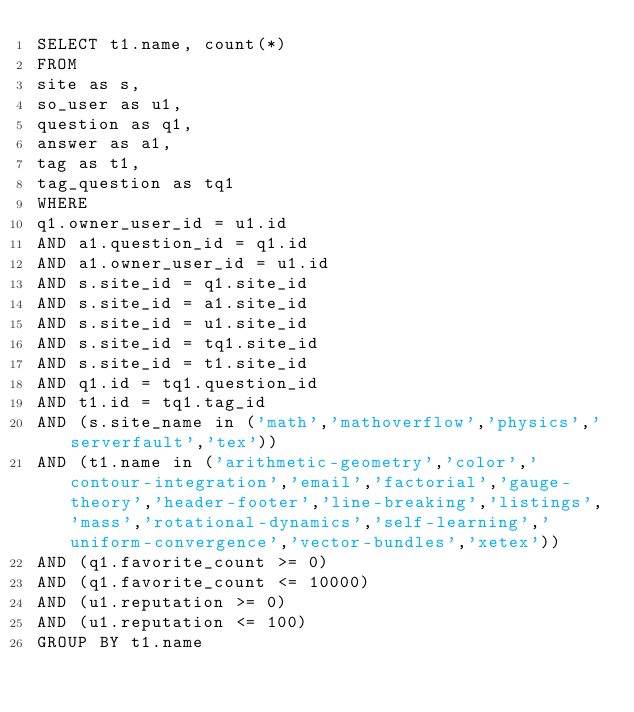Convert code to text. <code><loc_0><loc_0><loc_500><loc_500><_SQL_>SELECT t1.name, count(*)
FROM
site as s,
so_user as u1,
question as q1,
answer as a1,
tag as t1,
tag_question as tq1
WHERE
q1.owner_user_id = u1.id
AND a1.question_id = q1.id
AND a1.owner_user_id = u1.id
AND s.site_id = q1.site_id
AND s.site_id = a1.site_id
AND s.site_id = u1.site_id
AND s.site_id = tq1.site_id
AND s.site_id = t1.site_id
AND q1.id = tq1.question_id
AND t1.id = tq1.tag_id
AND (s.site_name in ('math','mathoverflow','physics','serverfault','tex'))
AND (t1.name in ('arithmetic-geometry','color','contour-integration','email','factorial','gauge-theory','header-footer','line-breaking','listings','mass','rotational-dynamics','self-learning','uniform-convergence','vector-bundles','xetex'))
AND (q1.favorite_count >= 0)
AND (q1.favorite_count <= 10000)
AND (u1.reputation >= 0)
AND (u1.reputation <= 100)
GROUP BY t1.name</code> 